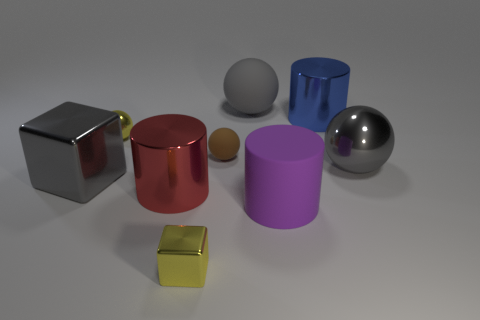Do the big blue thing and the brown thing that is behind the big gray metallic ball have the same shape?
Ensure brevity in your answer.  No. What is the large ball that is behind the large shiny thing behind the tiny yellow metallic thing behind the big shiny block made of?
Offer a very short reply. Rubber. Are there any gray blocks that have the same size as the yellow block?
Give a very brief answer. No. What size is the yellow block that is made of the same material as the large red object?
Give a very brief answer. Small. What is the shape of the small rubber thing?
Provide a succinct answer. Sphere. Are the red cylinder and the big sphere behind the small brown sphere made of the same material?
Provide a succinct answer. No. What number of things are either large gray objects or small brown rubber things?
Your answer should be compact. 4. Are any small matte spheres visible?
Your response must be concise. Yes. There is a gray metal object that is left of the tiny yellow metal object that is in front of the yellow sphere; what is its shape?
Offer a terse response. Cube. How many objects are yellow things that are behind the yellow shiny block or gray objects that are left of the big purple matte object?
Provide a succinct answer. 3. 